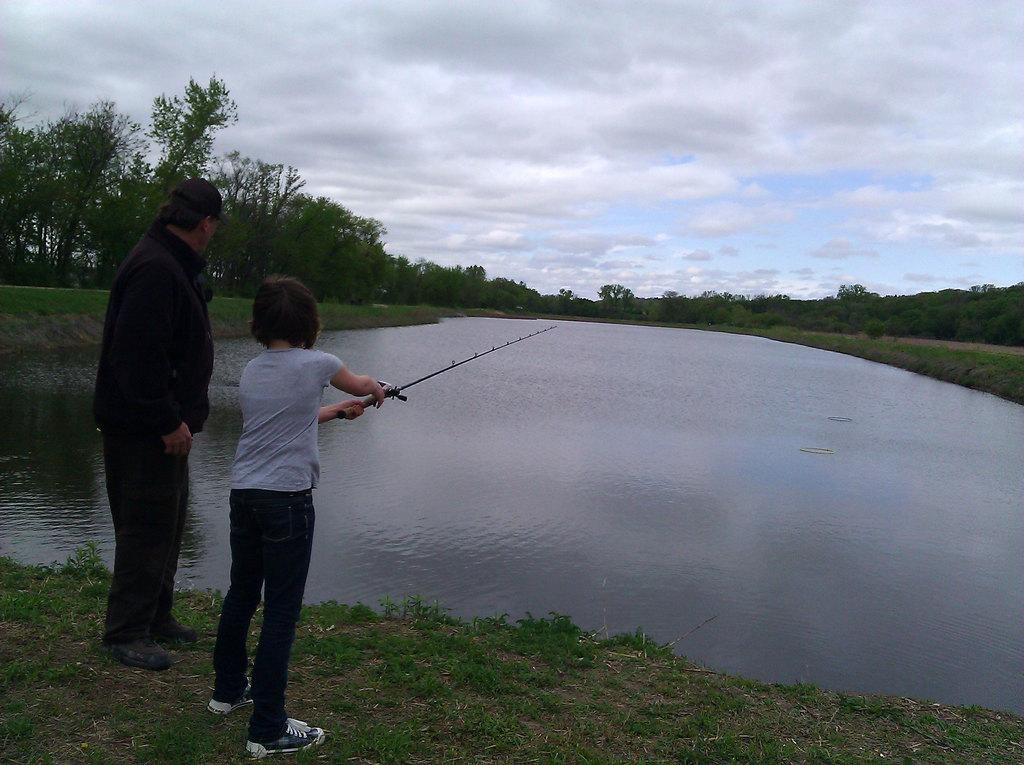How many people are present in the image? There are two people standing in the image. What is the kid holding in the image? The kid is holding a fishing rod in the image. What type of environment is visible in the image? There is water, grass, trees, and the sky visible in the image. What can be seen in the background of the image? Trees and the sky are visible in the background of the image. What is the weather like in the image? The presence of clouds in the sky suggests that it might be partly cloudy. What type of building can be seen in the image? There is no building present in the image; it features two people and a kid holding a fishing rod in a natural setting. Is the kid driving a vehicle in the image? No, the kid is not driving a vehicle in the image; they are holding a fishing rod. 